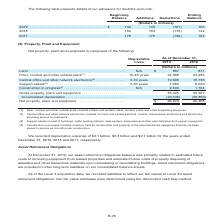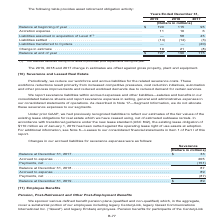According to Centurylink's financial document, What are the 2019, 2018 and 2017 change in estimates offset against? gross property, plant and equipment. The document states: "Gross property, plant and equipment . 55,425 53,267 Accumulated depreciation . (29,346) (26,859)..." Also, What do the liabilities assumed in acquisition of Level 3 during 2018 relate to? purchase price adjustments during the year. The document states: "(1) The liabilities assumed during 2018 relate to purchase price adjustments during the year...." Also, Which years are considered in the table providing asset retirement obligation activity? The document contains multiple relevant values: 2019, 2018, 2017. From the document: "19 . $ 142 145 (181) 106 2018 . 164 153 (175) 142 2017 . 178 176 (190) 164 (Dollars in millions) 2019 . $ 142 145 (181) 106 2018 . 164 153 (175) 142 2..." Additionally, Which year has the largest accretion expense? According to the financial document, 2019. The relevant text states: "(Dollars in millions) 2019 . $ 142 145 (181) 106 2018 . 164 153 (175) 142 2017 . 178 176 (190) 164..." Also, can you calculate: What is the change in balance at end of year in 2019 from 2018? Based on the calculation: 197-190, the result is 7 (in millions). This is based on the information: "Balance at end of year . $ 197 190 115 181) 106 2018 . 164 153 (175) 142 2017 . 178 176 (190) 164..." The key data points involved are: 190, 197. Also, can you calculate: What is the average accretion expense across 2017, 2018 and 2019? To answer this question, I need to perform calculations using the financial data. The calculation is: (11+10+6)/3, which equals 9 (in millions). This is based on the information: "inning of year . $ 190 115 95 Accretion expense . 11 10 6 Liabilities assumed in acquisition of Level 3 (1) . — 58 45 Liabilities settled . (14) (14) (3 ing of year . $ 190 115 95 Accretion expense . ..." The key data points involved are: 10, 11, 6. 